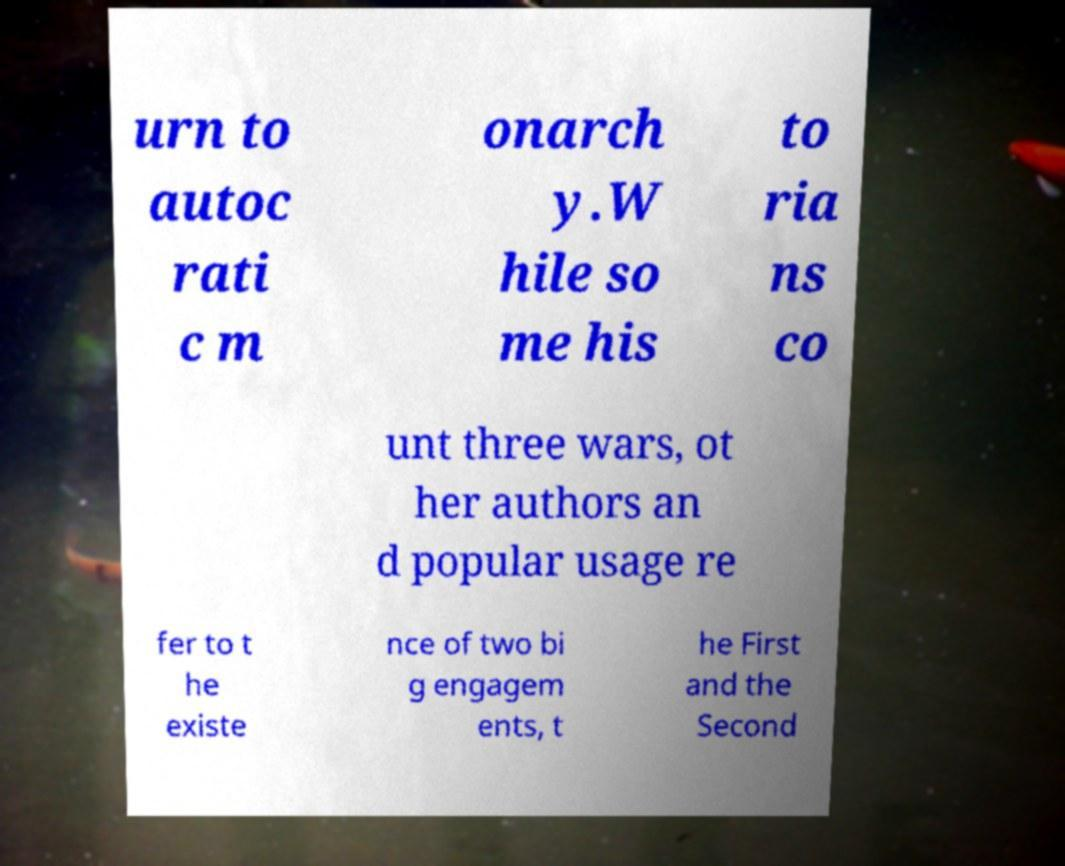What messages or text are displayed in this image? I need them in a readable, typed format. urn to autoc rati c m onarch y.W hile so me his to ria ns co unt three wars, ot her authors an d popular usage re fer to t he existe nce of two bi g engagem ents, t he First and the Second 